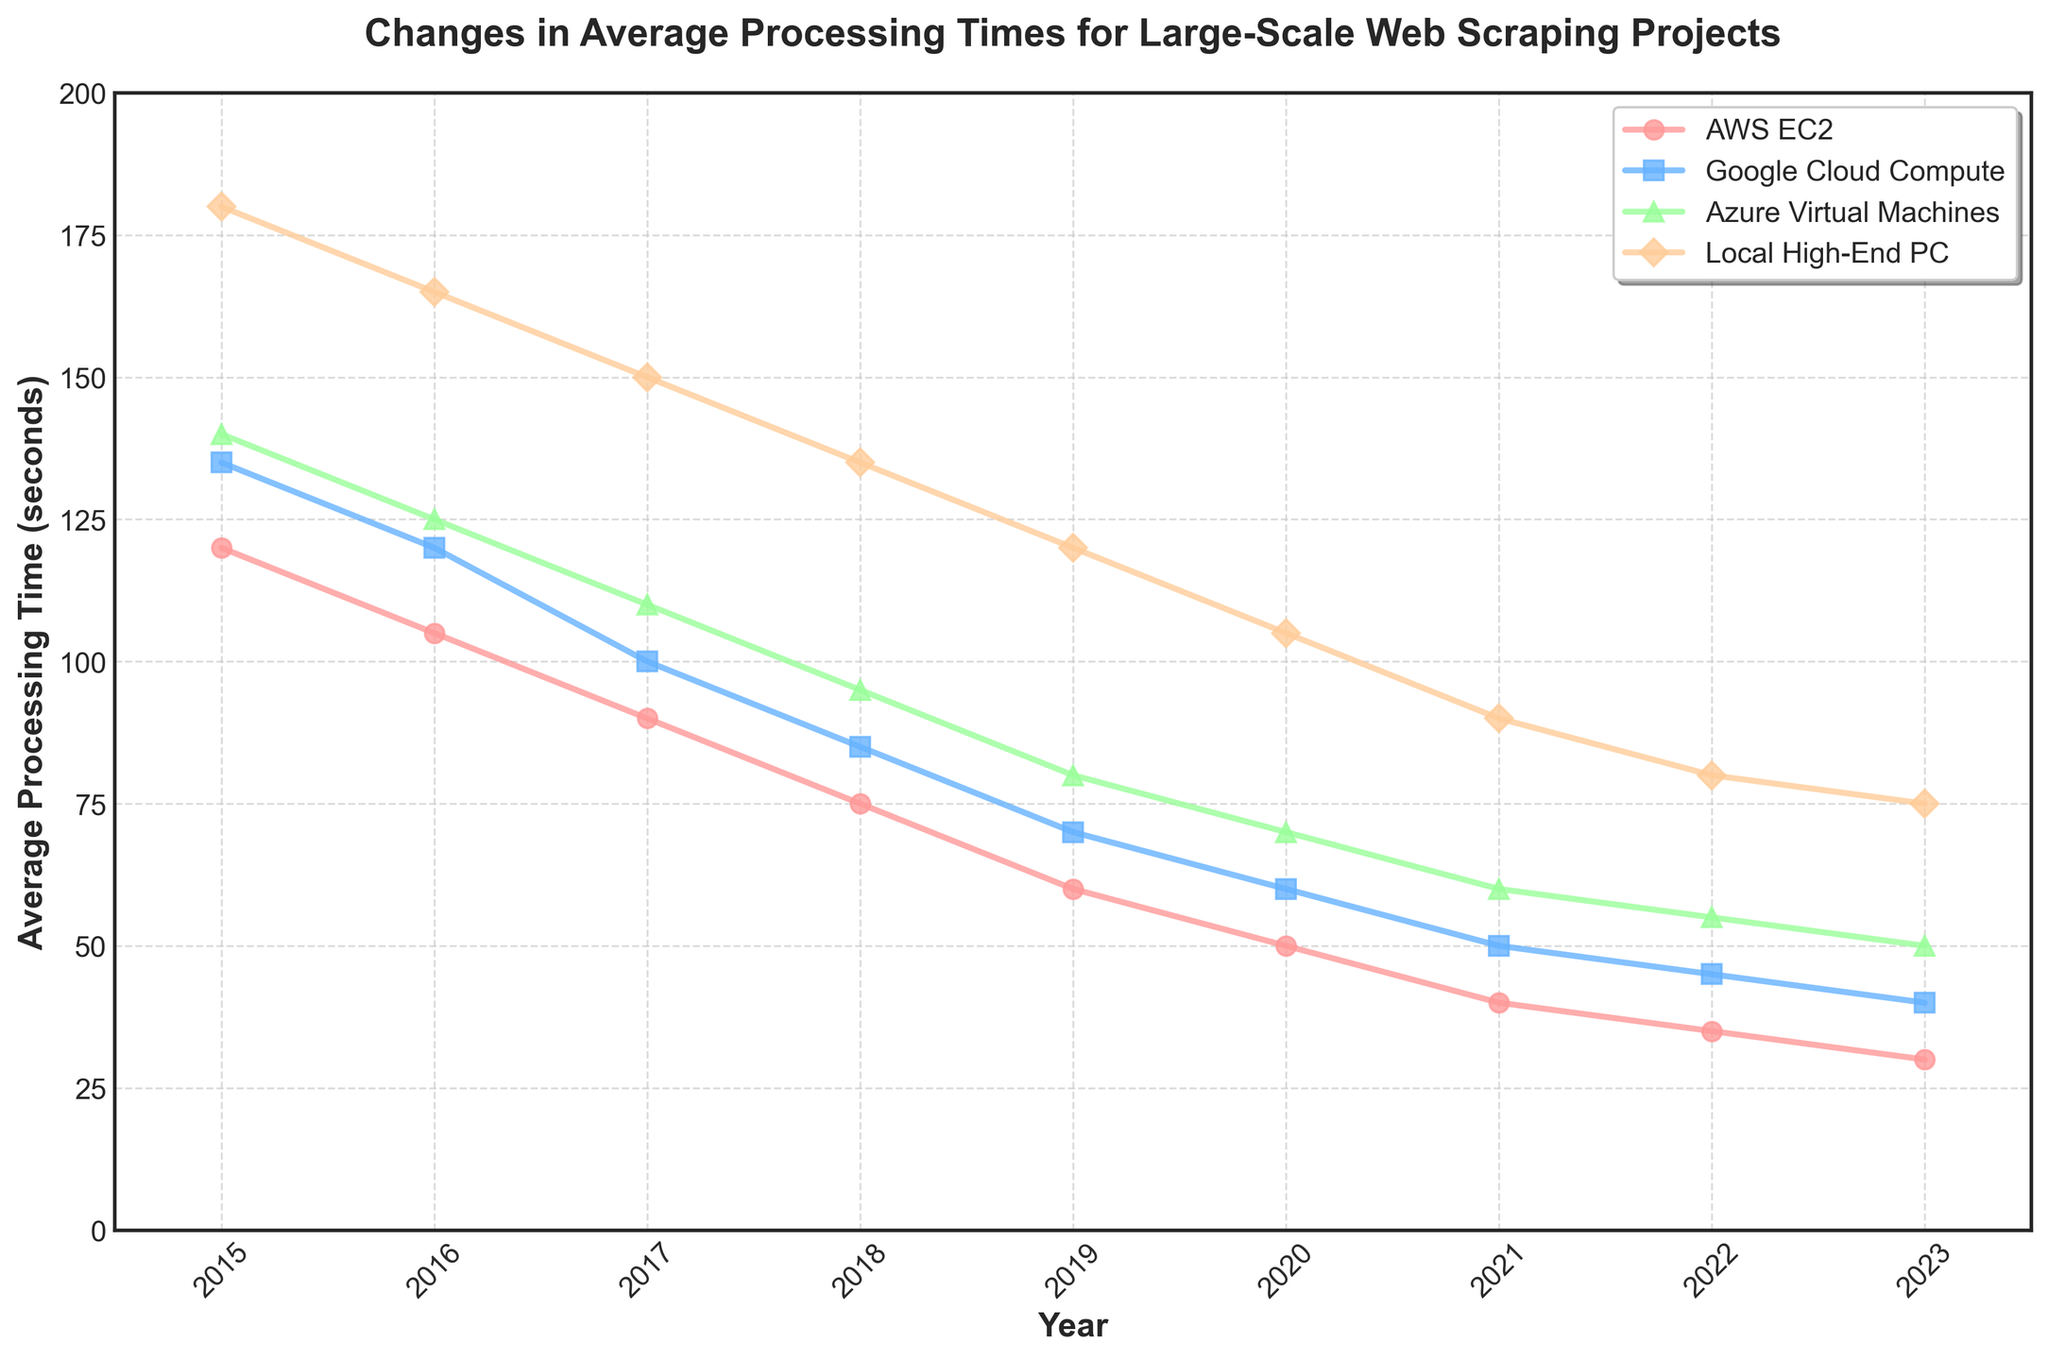Which provider had the highest average processing time in 2015? In 2015, the Local High-End PC had the highest average processing time, indicated by it having the highest point on the chart for that year.
Answer: Local High-End PC How did the processing time of AWS EC2 change between 2015 and 2020? AWS EC2 started at 120 seconds in 2015 and decreased to 50 seconds by 2020. The change is calculated as 120 - 50 = 70 seconds.
Answer: Decreased by 70 seconds Compare the processing times of Google Cloud Compute and Azure Virtual Machines in 2019. Which one was faster? In 2019, Google Cloud Compute had an average processing time of 70 seconds, while Azure Virtual Machines had 80 seconds. Since 70 < 80, Google Cloud Compute was faster.
Answer: Google Cloud Compute What is the difference in average processing times between the fastest and slowest providers in 2023? In 2023, AWS EC2 was the fastest at 30 seconds, and the Local High-End PC was the slowest at 75 seconds. The difference is 75 - 30 = 45 seconds.
Answer: 45 seconds What trend do you notice about the average processing times for the Local High-End PC from 2015 to 2023? The Local High-End PC shows a decreasing trend in average processing times from 180 seconds in 2015 to 75 seconds in 2023.
Answer: Decreasing trend By how much did the processing time for Azure Virtual Machines improve from 2016 to 2021? Azure Virtual Machines had an average processing time of 125 seconds in 2016 and 60 seconds in 2021. The improvement is calculated as 125 - 60 = 65 seconds.
Answer: Improved by 65 seconds What was the percentage decrease in Google Cloud Compute's processing time from 2016 to 2019? In 2016, Google Cloud Compute's processing time was 120 seconds, and in 2019, it was 70 seconds. The percentage decrease = ((120 - 70) / 120) * 100% = 41.67%.
Answer: 41.67% Which provider had the most significant reduction in processing time between 2015 and 2023? AWS EC2 had the most significant reduction, going from 120 seconds in 2015 to 30 seconds in 2023. The reduction is 120 - 30 = 90 seconds.
Answer: AWS EC2 Which year did all providers see a decrease in processing time compared to the previous year? Examining the values year by year, each provider saw a decrease in average processing time every year from 2015 to 2023.
Answer: Every year During which year did Google Cloud Compute have the same processing time as the Local High-End PC? In 2016, Google Cloud Compute had an average processing time of 120 seconds, which also matched the Local High-End PC's processing time in 2016.
Answer: 2016 